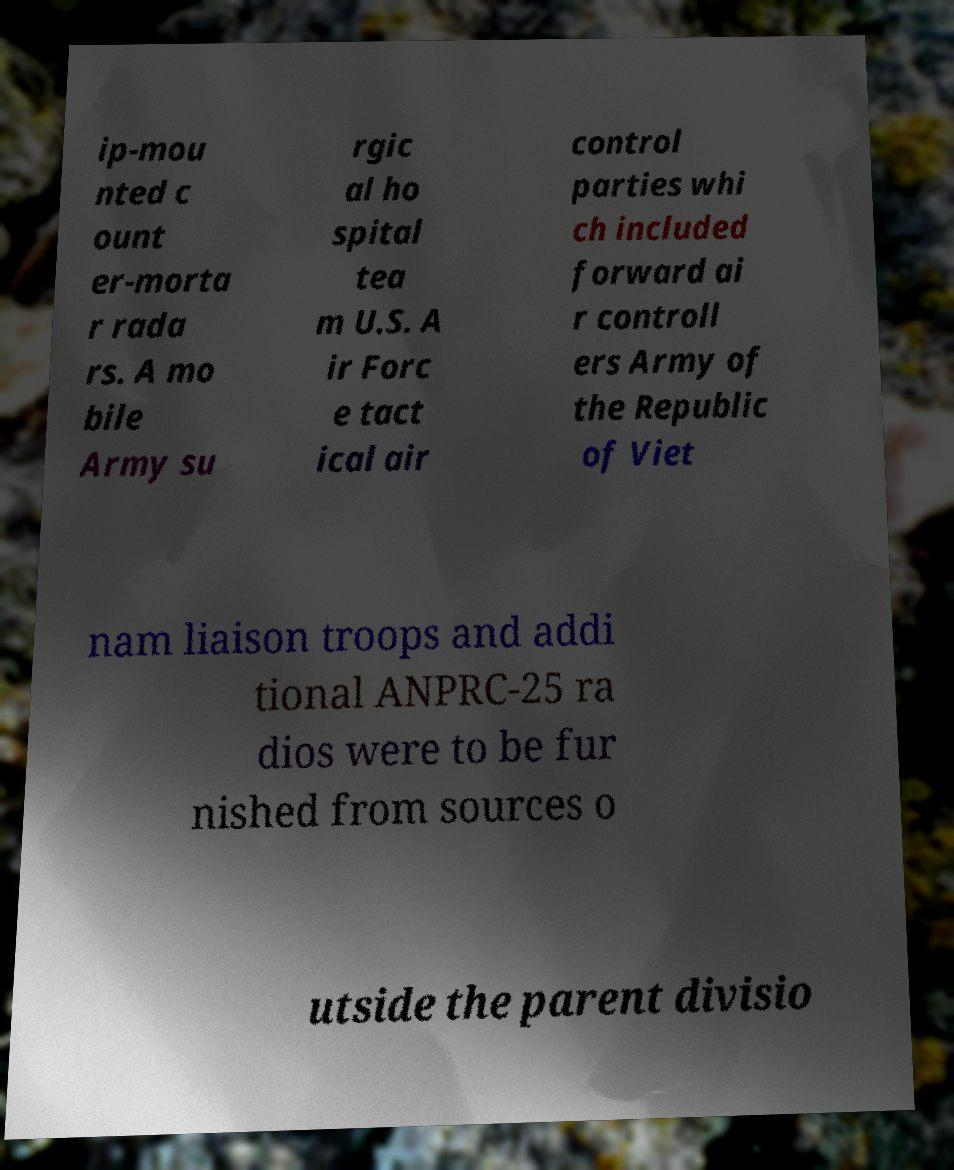Please read and relay the text visible in this image. What does it say? ip-mou nted c ount er-morta r rada rs. A mo bile Army su rgic al ho spital tea m U.S. A ir Forc e tact ical air control parties whi ch included forward ai r controll ers Army of the Republic of Viet nam liaison troops and addi tional ANPRC-25 ra dios were to be fur nished from sources o utside the parent divisio 